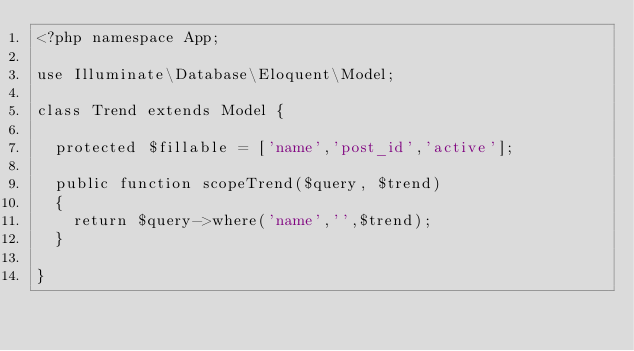<code> <loc_0><loc_0><loc_500><loc_500><_PHP_><?php namespace App;

use Illuminate\Database\Eloquent\Model;

class Trend extends Model {

	protected $fillable = ['name','post_id','active'];

	public function scopeTrend($query, $trend)
	{
		return $query->where('name','',$trend);
	}

}
</code> 